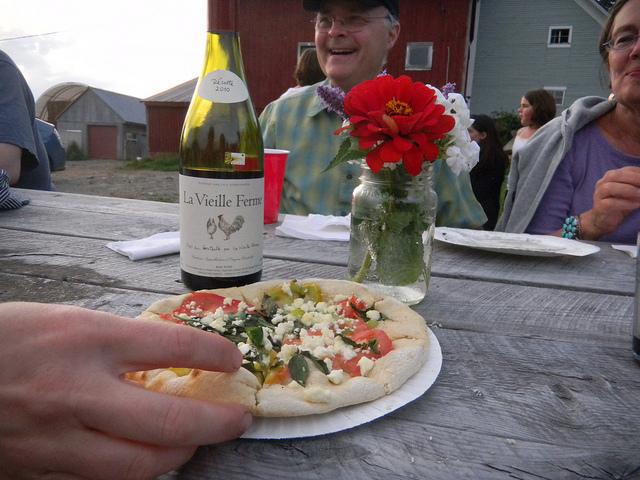How many glasses are on the table?
Give a very brief answer. 1. What food is on the man's plate?
Be succinct. Pizza. How many bottles are there?
Quick response, please. 1. What toppings are on the pizza?
Be succinct. Pepperoni. What does the wine bottle say?
Write a very short answer. La vieille ferme. What is the man eating?
Concise answer only. Pizza. What is in the vase?
Short answer required. Flowers. What is in the bottle?
Quick response, please. Wine. Does this pizza look healthy?
Write a very short answer. Yes. How many slices of pizza?
Quick response, please. 4. 